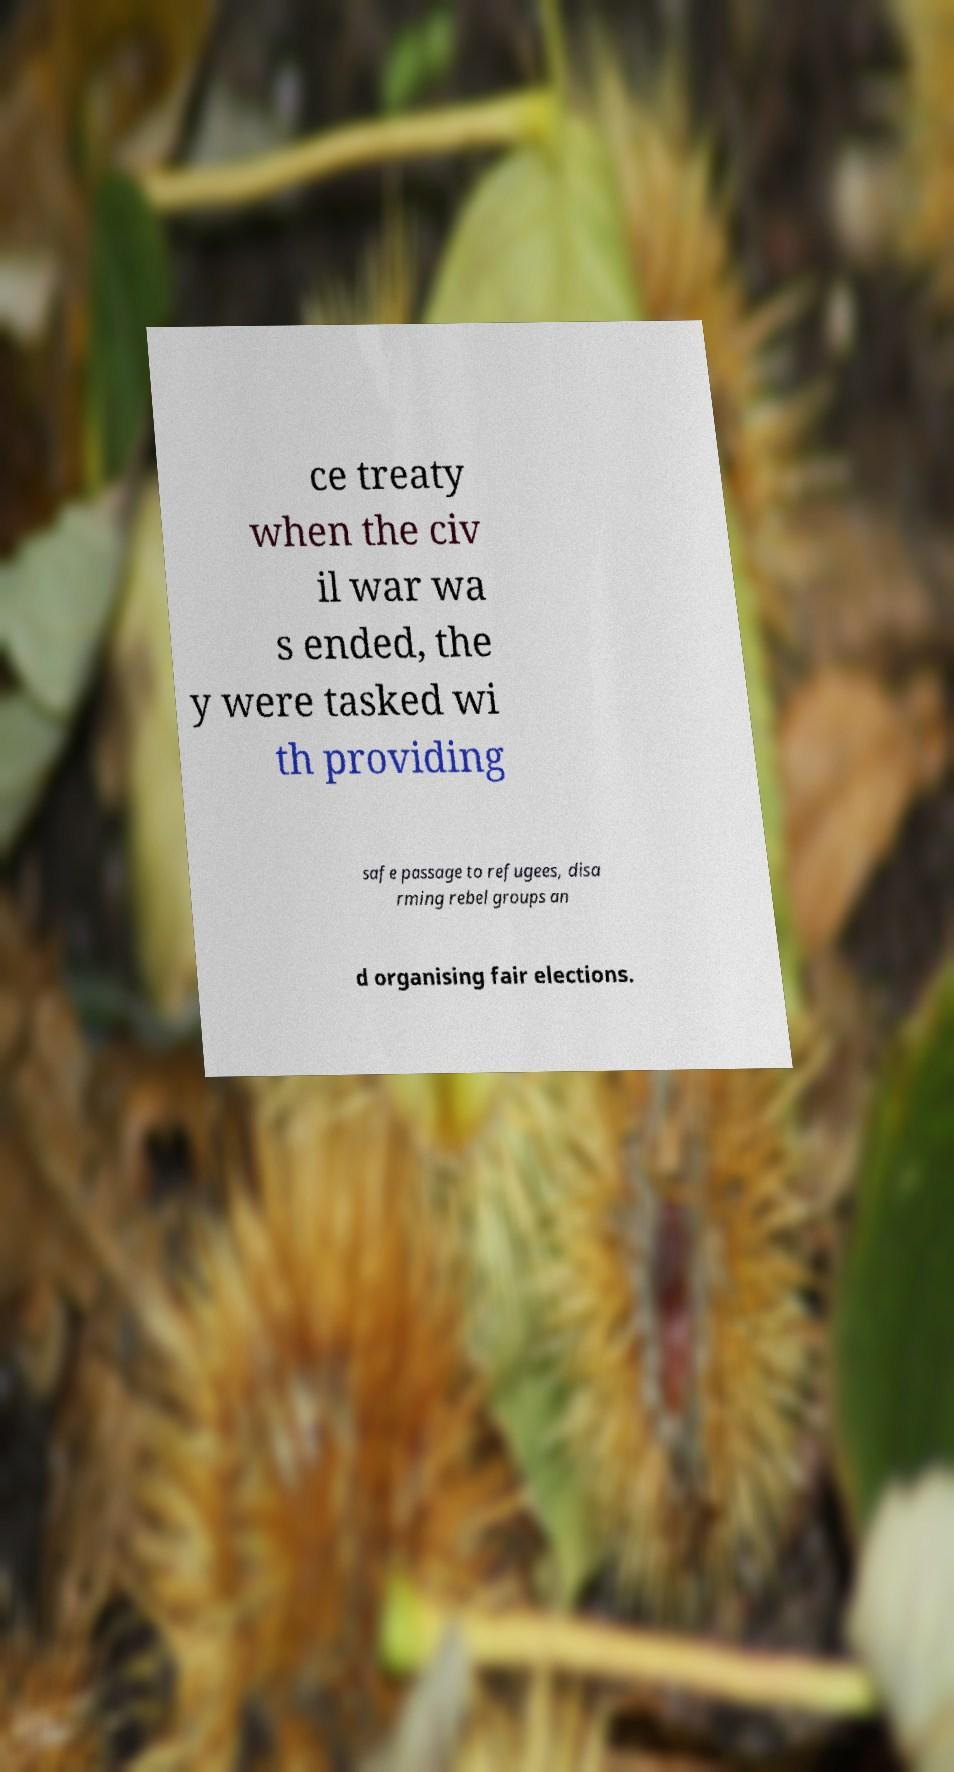Can you read and provide the text displayed in the image?This photo seems to have some interesting text. Can you extract and type it out for me? ce treaty when the civ il war wa s ended, the y were tasked wi th providing safe passage to refugees, disa rming rebel groups an d organising fair elections. 